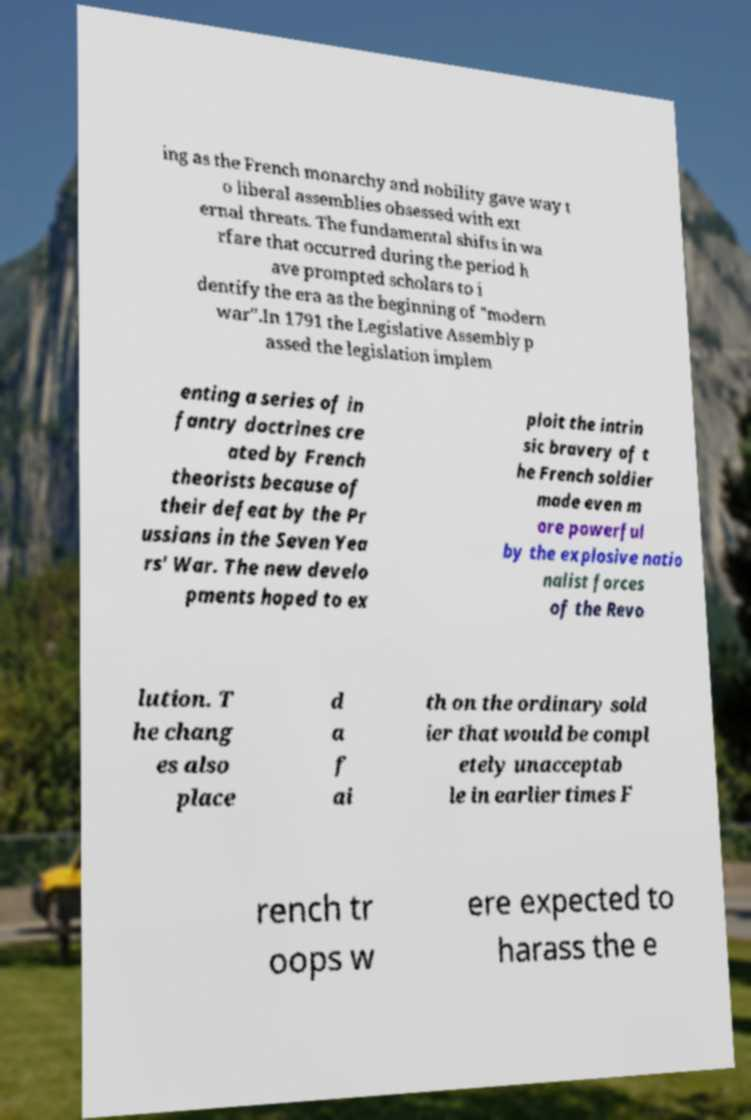There's text embedded in this image that I need extracted. Can you transcribe it verbatim? ing as the French monarchy and nobility gave way t o liberal assemblies obsessed with ext ernal threats. The fundamental shifts in wa rfare that occurred during the period h ave prompted scholars to i dentify the era as the beginning of "modern war".In 1791 the Legislative Assembly p assed the legislation implem enting a series of in fantry doctrines cre ated by French theorists because of their defeat by the Pr ussians in the Seven Yea rs' War. The new develo pments hoped to ex ploit the intrin sic bravery of t he French soldier made even m ore powerful by the explosive natio nalist forces of the Revo lution. T he chang es also place d a f ai th on the ordinary sold ier that would be compl etely unacceptab le in earlier times F rench tr oops w ere expected to harass the e 